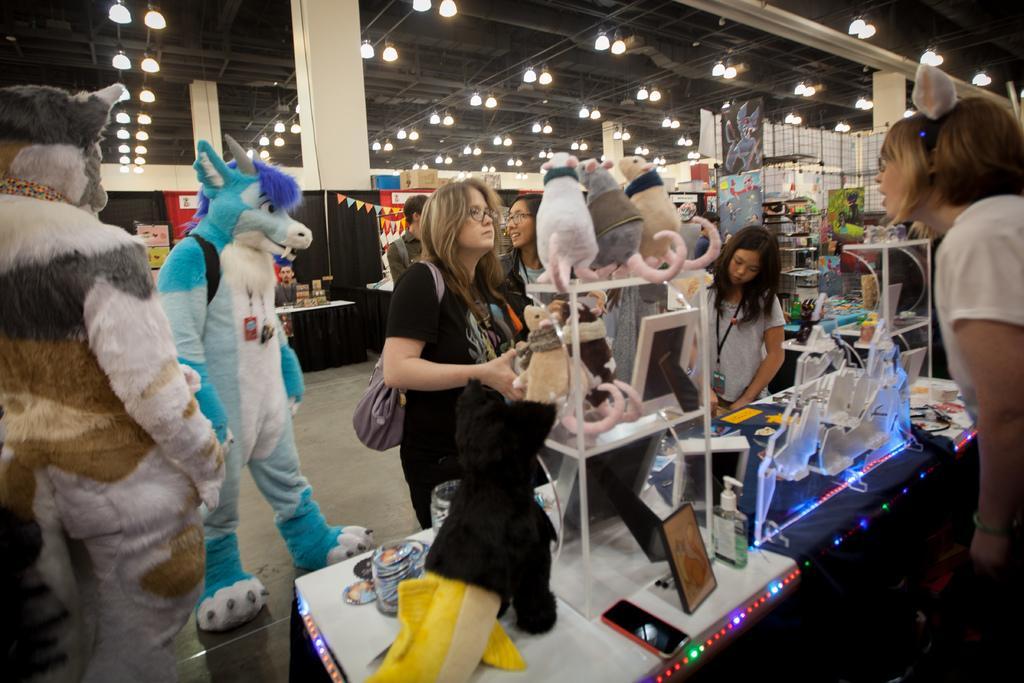Please provide a concise description of this image. The image is clicked in a mall. In the foreground of the picture there are people, toys, frames, lights, desk, mobile, mascots and many other objects. At the top there are lights, pipes and ceiling. In the center of the picture there are pillars, racks, boards, tables, banners and various objects. 